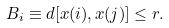Convert formula to latex. <formula><loc_0><loc_0><loc_500><loc_500>B _ { i } \equiv d [ x ( i ) , x ( j ) ] \leq r .</formula> 